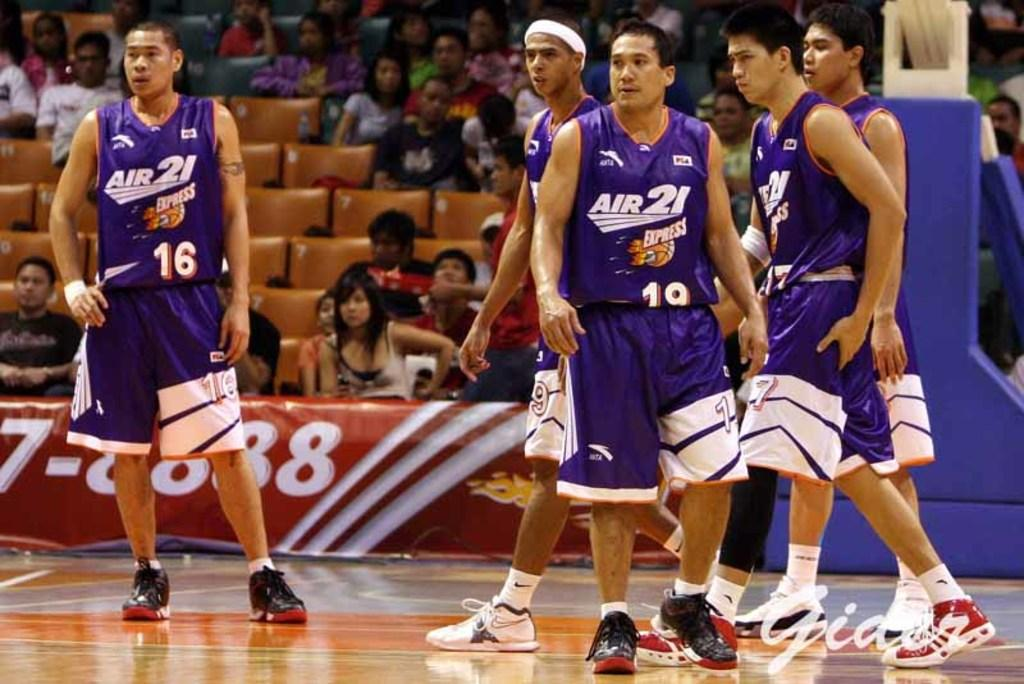<image>
Create a compact narrative representing the image presented. Basketball players wear bright and colorful Air 21 uniforms. 